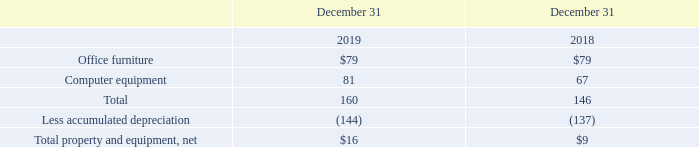Note 3 − Property and Equipment
Our major classes of property and equipment were as follows:
Depreciation expense for the years ended December 31, 2019 and 2018 was $7, and $18, respectively.
What is the depreciation expense for 2019? $7. What is the amount spent on computer equipment in 2018? 67. What is the amount spent on office furniture in 2019? $79. What is the percentage change for depreciation expense in 2019?
Answer scale should be: percent. (7-18)/18 
Answer: -61.11. What is the total amount spent on computer equipment in 2018 and 2019? 81 + 67 
Answer: 148. Which year has a higher total sum of 'Depreciation expense' and 'Total property and equipment, net'? (9 + 18) > (16 + 7)
Answer: 2018. 